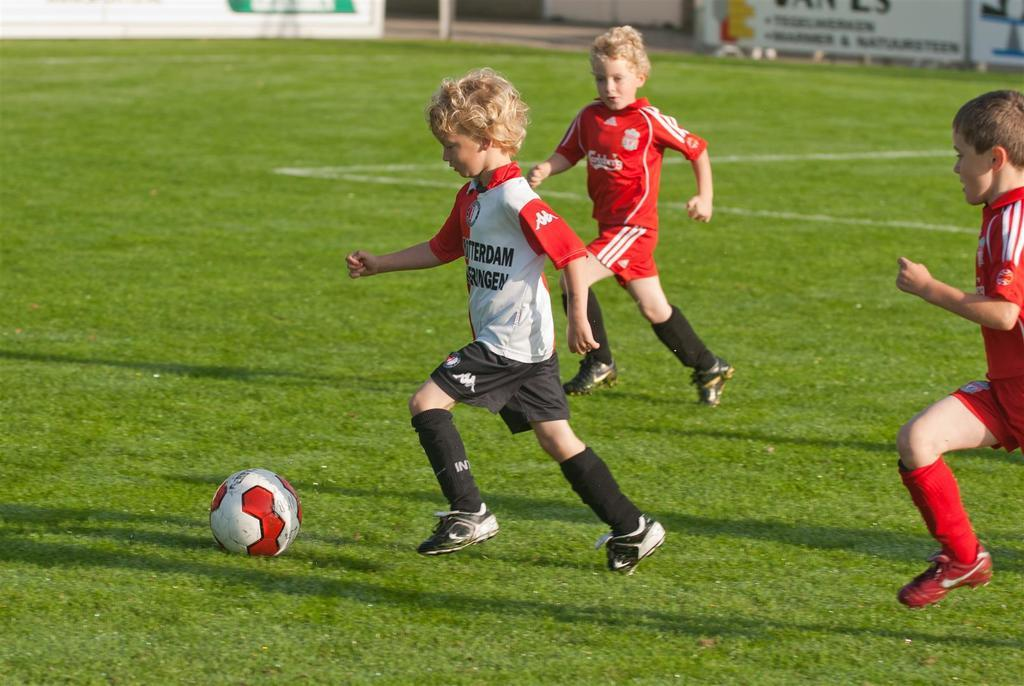How many children are present in the image? There are three children in the image. What are the children doing in the image? The children are running on the ground. What can be seen in the background of the image? There is an advertisement and a ball in the background of the image. What type of hammer is being used by the children in the image? There is no hammer present in the image; the children are running on the ground. What type of competition are the children participating in the image? There is no competition present in the image; the children are simply running on the ground. 